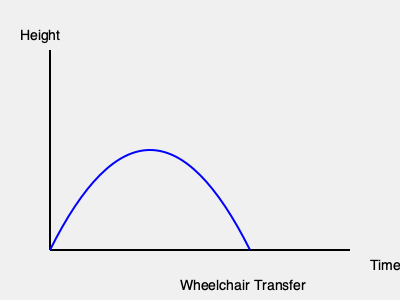Analyze the 3D motion capture data represented in the graph above, which shows the vertical displacement of a person's center of mass during a wheelchair transfer. If the transfer takes 2 seconds to complete and the maximum height reached is 0.5 meters, what is the average vertical velocity (in m/s) during the ascending phase of the transfer? To solve this problem, we need to follow these steps:

1. Identify the ascending phase of the transfer:
   The ascending phase is represented by the first half of the curve, from the starting point to the peak.

2. Determine the time for the ascending phase:
   Since the entire transfer takes 2 seconds, we can assume the ascending phase takes half of that time.
   Time for ascending phase = 2 seconds ÷ 2 = 1 second

3. Calculate the vertical displacement:
   The vertical displacement is the difference between the maximum height and the starting height.
   Vertical displacement = Maximum height - Starting height
   Vertical displacement = 0.5 meters - 0 meters = 0.5 meters

4. Calculate the average vertical velocity:
   The average velocity is given by the formula: $v = \frac{\Delta d}{\Delta t}$
   Where $\Delta d$ is the change in displacement and $\Delta t$ is the change in time.

   $v_{avg} = \frac{0.5 \text{ m}}{1 \text{ s}} = 0.5 \text{ m/s}$

Therefore, the average vertical velocity during the ascending phase of the transfer is 0.5 m/s.
Answer: 0.5 m/s 